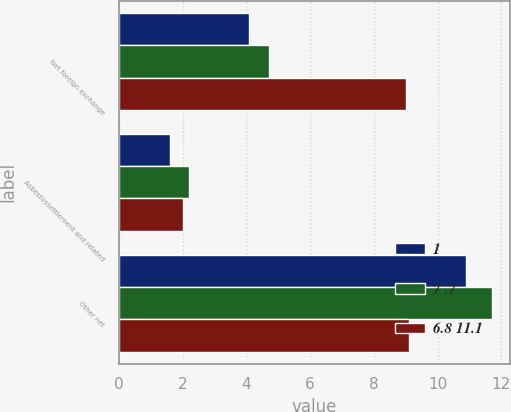<chart> <loc_0><loc_0><loc_500><loc_500><stacked_bar_chart><ecel><fcel>Net foreign exchange<fcel>Asbestossettlement and related<fcel>Other net<nl><fcel>1<fcel>4.1<fcel>1.6<fcel>10.9<nl><fcel>7 .7<fcel>4.7<fcel>2.2<fcel>11.7<nl><fcel>6.8 11.1<fcel>9<fcel>2<fcel>9.1<nl></chart> 